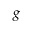Convert formula to latex. <formula><loc_0><loc_0><loc_500><loc_500>g</formula> 